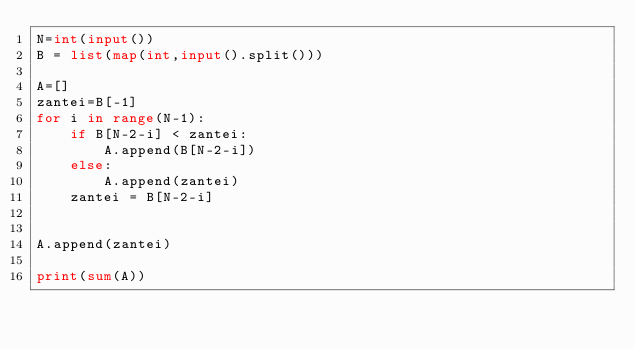<code> <loc_0><loc_0><loc_500><loc_500><_Python_>N=int(input())
B = list(map(int,input().split()))

A=[]
zantei=B[-1]
for i in range(N-1):
    if B[N-2-i] < zantei:
        A.append(B[N-2-i])
    else:
        A.append(zantei)
    zantei = B[N-2-i]


A.append(zantei)

print(sum(A))</code> 